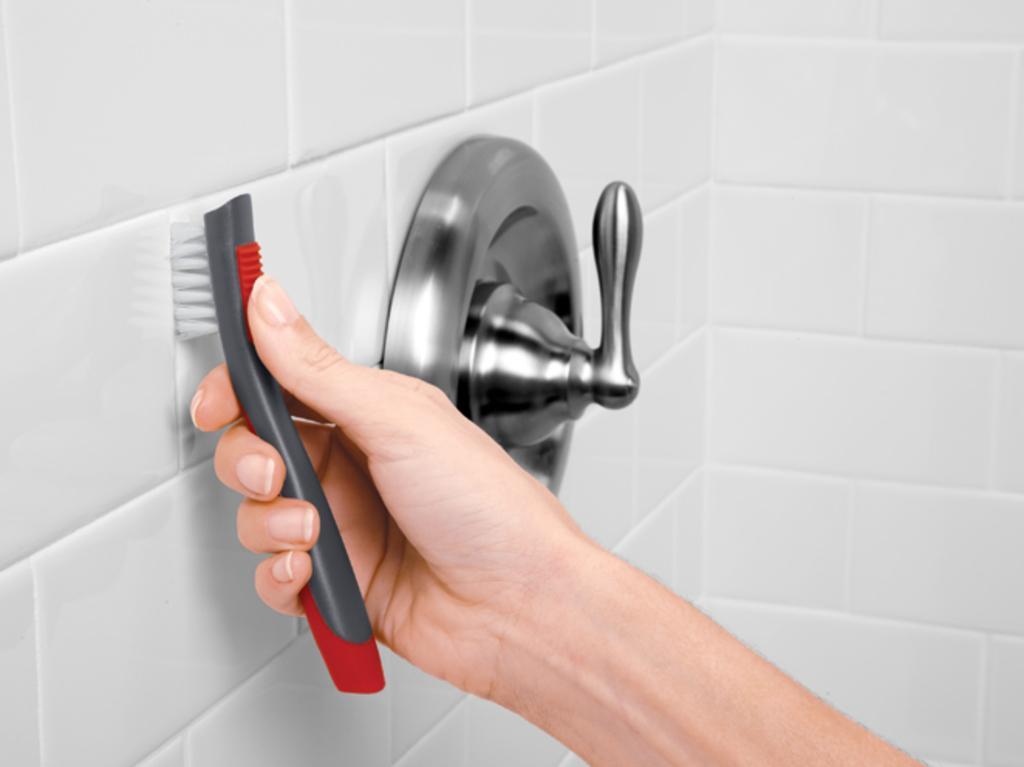Could you give a brief overview of what you see in this image? In the picture we can see a washroom wall with white color tiles and a person hand with a brush pressing to the wall and beside it we can see a tap handle to the wall. 